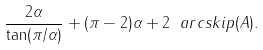Convert formula to latex. <formula><loc_0><loc_0><loc_500><loc_500>\frac { 2 \alpha } { \tan ( \pi / \alpha ) } + ( \pi - 2 ) \alpha + 2 \ a r c s k i p ( A ) .</formula> 